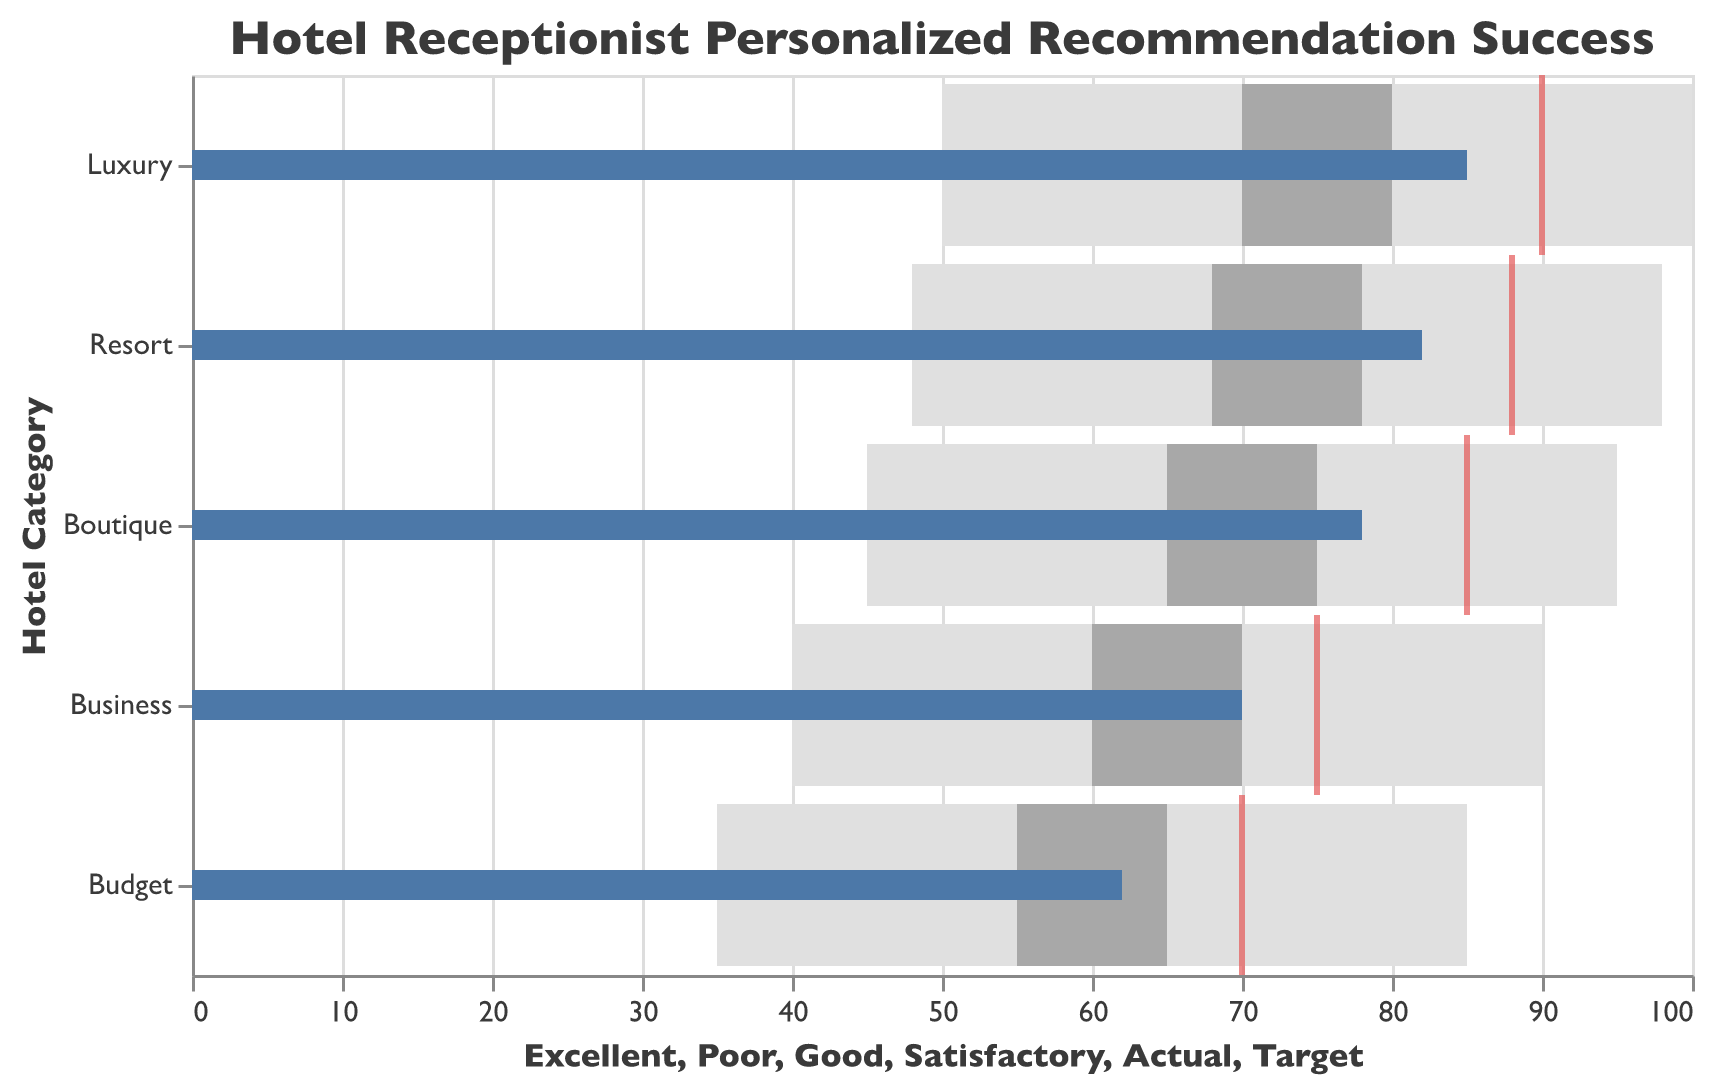What is the title of the plot? The title of the plot is displayed at the top. It reads "Hotel Receptionist Personalized Recommendation Success."
Answer: Hotel Receptionist Personalized Recommendation Success Which hotel category has the highest percentage of successful personalized recommendations? The highest percentage is indicated by the Actual bar reaching the highest value. For Luxury hotels, the Actual percentage is 85%, which is the highest among all categories.
Answer: Luxury What is the difference between the Actual and Target percentages for Business hotels? Subtract the Actual percentage from the Target percentage for Business hotels. Target is 75% and Actual is 70%, so the difference is 75 - 70.
Answer: 5% Which hotel categories achieve an Actual percentage above their respective Good thresholds? Compare the Actual percentages with the Good thresholds. For Luxury (85 > 80) and Resort (82 > 78), the Actual percentages exceed their Good thresholds.
Answer: Luxury, Resort Is the Actual performance of Budget hotels within the Satisfactory range? Check if the Actual percentage for Budget hotels falls within the Satisfactory range. The Satisfactory range for Budget is 55% - 65%, and Actual is 62%.
Answer: Yes Which hotel category has the smallest gap between Poor and Excellent ranges? Calculate the differences between Poor and Excellent ranges for all categories: 
Luxury: 100 - 50 = 50
Boutique: 95 - 45 = 50
Resort: 98 - 48 = 50
Business: 90 - 40 = 50
Budget: 85 - 35 = 50
All have the same gap of 50.
Answer: All categories What is the color used to represent the Target performance tick? The Target performance is represented by a red tick, which is visually distinct from other elements.
Answer: Red Which hotel category has the lowest Actual percentage? Identify the bar with the smallest length. For Budget hotels, the Actual percentage is 62%, which is the lowest among all categories.
Answer: Budget 